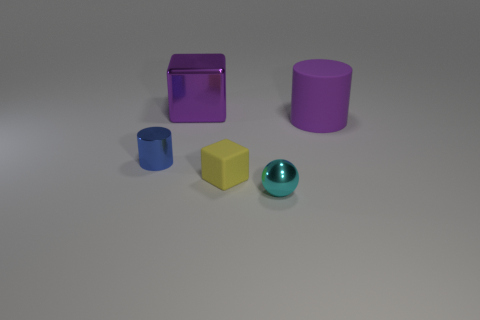The big rubber object that is to the right of the small blue thing that is behind the tiny metallic object that is in front of the blue metal thing is what shape?
Give a very brief answer. Cylinder. Are there fewer large metallic objects to the right of the cyan metallic object than blue things behind the large metal thing?
Offer a terse response. No. Is the shape of the small shiny thing behind the small yellow cube the same as the purple thing that is left of the big purple matte cylinder?
Your answer should be compact. No. There is a tiny matte thing that is left of the small cyan shiny ball to the right of the yellow block; what shape is it?
Provide a short and direct response. Cube. There is a thing that is the same color as the large cylinder; what size is it?
Keep it short and to the point. Large. Is there a tiny blue object that has the same material as the purple cube?
Provide a succinct answer. Yes. What is the block behind the blue shiny cylinder made of?
Ensure brevity in your answer.  Metal. What is the material of the cyan ball?
Provide a succinct answer. Metal. Does the purple object in front of the purple cube have the same material as the large block?
Provide a short and direct response. No. Are there fewer small yellow objects that are right of the tiny cyan thing than small shiny things?
Your answer should be compact. Yes. 